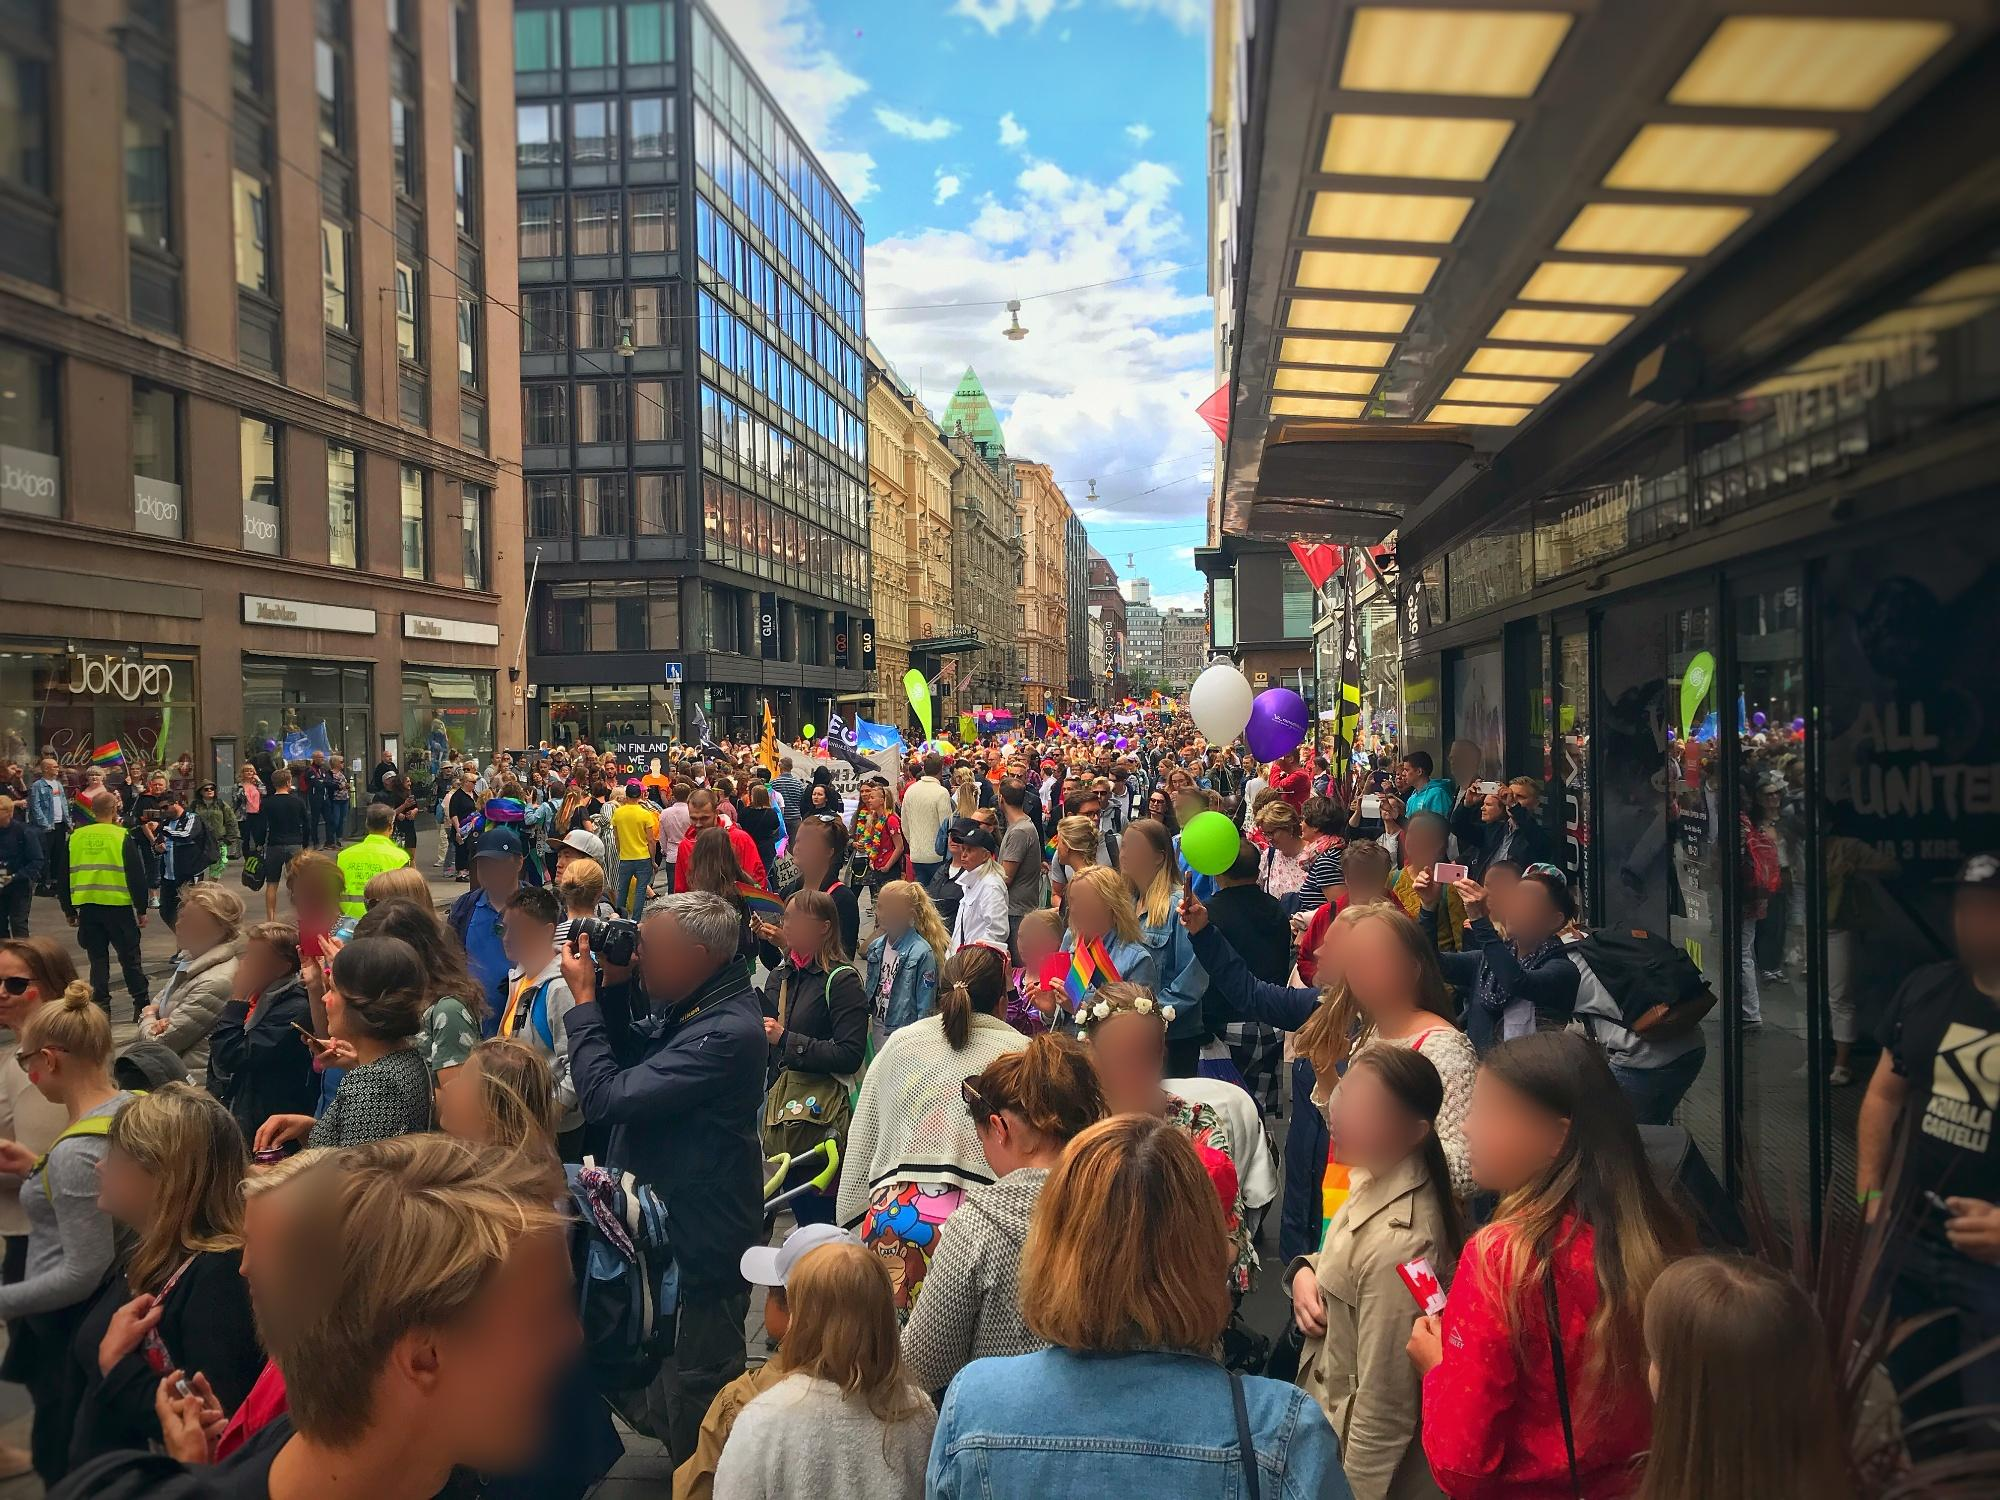Why might the buildings in the background be significant to Helsinki’s identity? The buildings in the background, with their mix of modern and classic architecture, encapsulate the essence of Helsinki’s urban identity. The large, reflective windows and sleek facades of the newer buildings symbolize the city’s modern development and progressive spirit. Meanwhile, the older, more traditional parts of the architecture hint at Helsinki's rich history and cultural heritage. This blend of old and new is significant as it represents how Helsinki embraces innovation while preserving its unique history, making it a city that respects its past while looking forward to the future. 